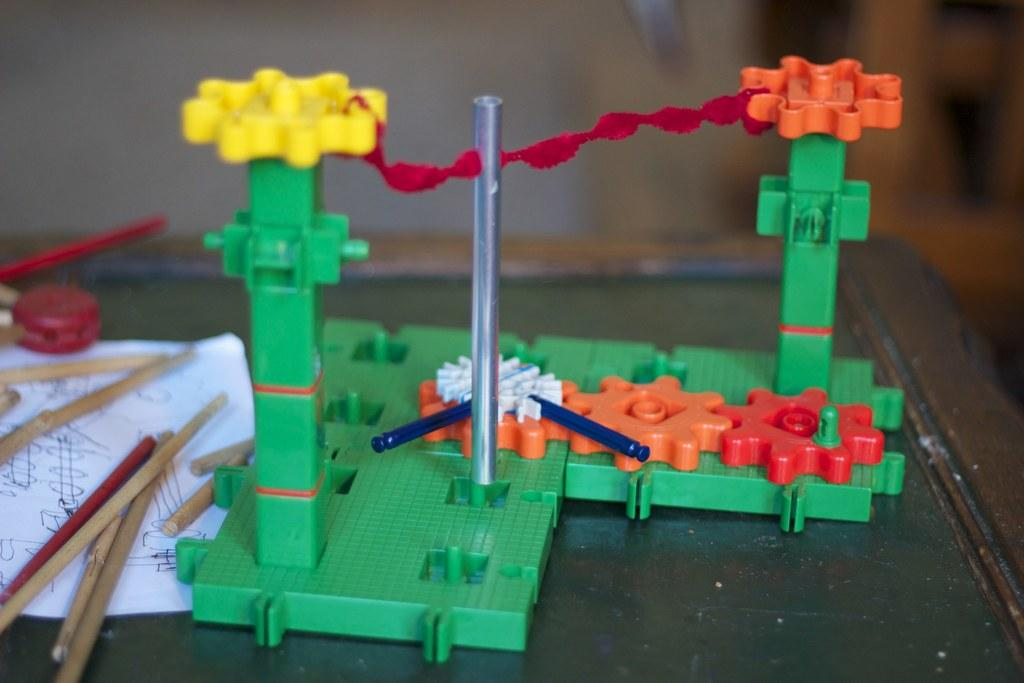What type of objects can be seen in the image? There are toys, wooden sticks, and paper in the image. Can you describe the unspecified things in the image? Unfortunately, the provided facts do not specify what these unspecified things are. What is the object in the image? The facts only mention that there is an object in the image, but it is not specified what that object is. What can be said about the background of the image? The background of the image is blurred. How many pizzas are being served for lunch in the image? There are no pizzas or references to lunch in the image. What type of credit is being offered for the objects in the image? There is no mention of credit or any financial transactions in the image. 